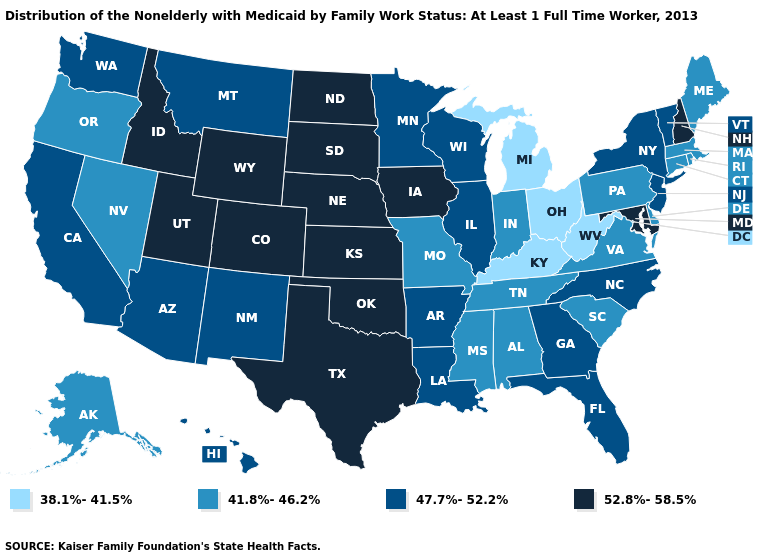What is the lowest value in states that border Tennessee?
Give a very brief answer. 38.1%-41.5%. What is the value of Indiana?
Be succinct. 41.8%-46.2%. Name the states that have a value in the range 47.7%-52.2%?
Write a very short answer. Arizona, Arkansas, California, Florida, Georgia, Hawaii, Illinois, Louisiana, Minnesota, Montana, New Jersey, New Mexico, New York, North Carolina, Vermont, Washington, Wisconsin. Does California have the lowest value in the USA?
Quick response, please. No. Among the states that border Delaware , which have the highest value?
Answer briefly. Maryland. What is the value of Ohio?
Answer briefly. 38.1%-41.5%. What is the value of Vermont?
Keep it brief. 47.7%-52.2%. Does the first symbol in the legend represent the smallest category?
Answer briefly. Yes. Does New Hampshire have the highest value in the USA?
Write a very short answer. Yes. Name the states that have a value in the range 52.8%-58.5%?
Quick response, please. Colorado, Idaho, Iowa, Kansas, Maryland, Nebraska, New Hampshire, North Dakota, Oklahoma, South Dakota, Texas, Utah, Wyoming. Which states have the lowest value in the West?
Be succinct. Alaska, Nevada, Oregon. Does Kentucky have the lowest value in the South?
Concise answer only. Yes. What is the value of South Carolina?
Write a very short answer. 41.8%-46.2%. What is the value of Tennessee?
Keep it brief. 41.8%-46.2%. 